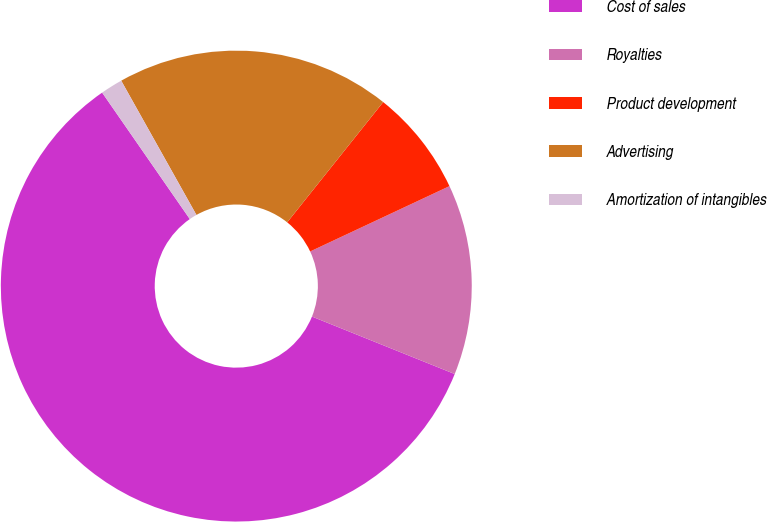Convert chart to OTSL. <chart><loc_0><loc_0><loc_500><loc_500><pie_chart><fcel>Cost of sales<fcel>Royalties<fcel>Product development<fcel>Advertising<fcel>Amortization of intangibles<nl><fcel>59.26%<fcel>13.07%<fcel>7.3%<fcel>18.85%<fcel>1.52%<nl></chart> 